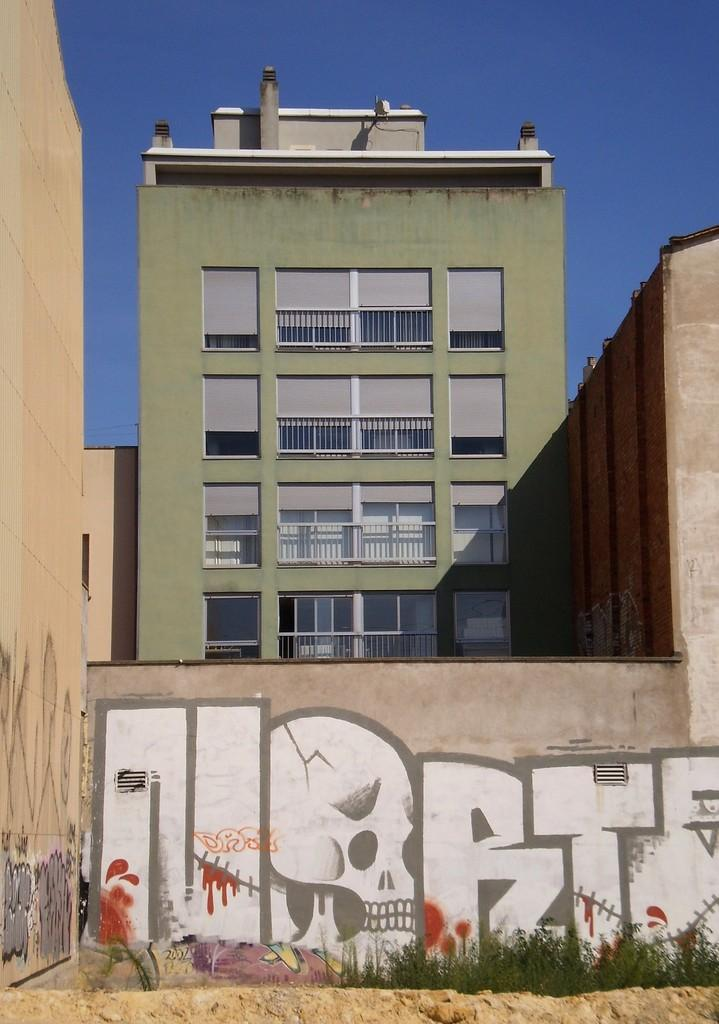What is hanging on the wall in the image? There is a painting on the wall in the image. Where is the painting located in relation to the image? The painting is at the bottom of the image. What can be seen in the background of the image? There is a building in the background of the image. What color is the sky in the image? The sky is blue at the top of the image. What type of jewel is being worn by the painting in the image? There is no jewel present in the image, as it features a painting on the wall and paintings do not wear jewelry. 